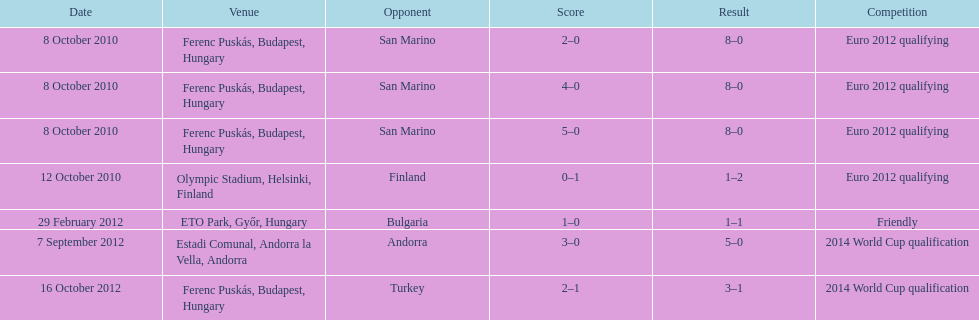How many goals did ádám szalai achieve against san marino in 2010? 3. 